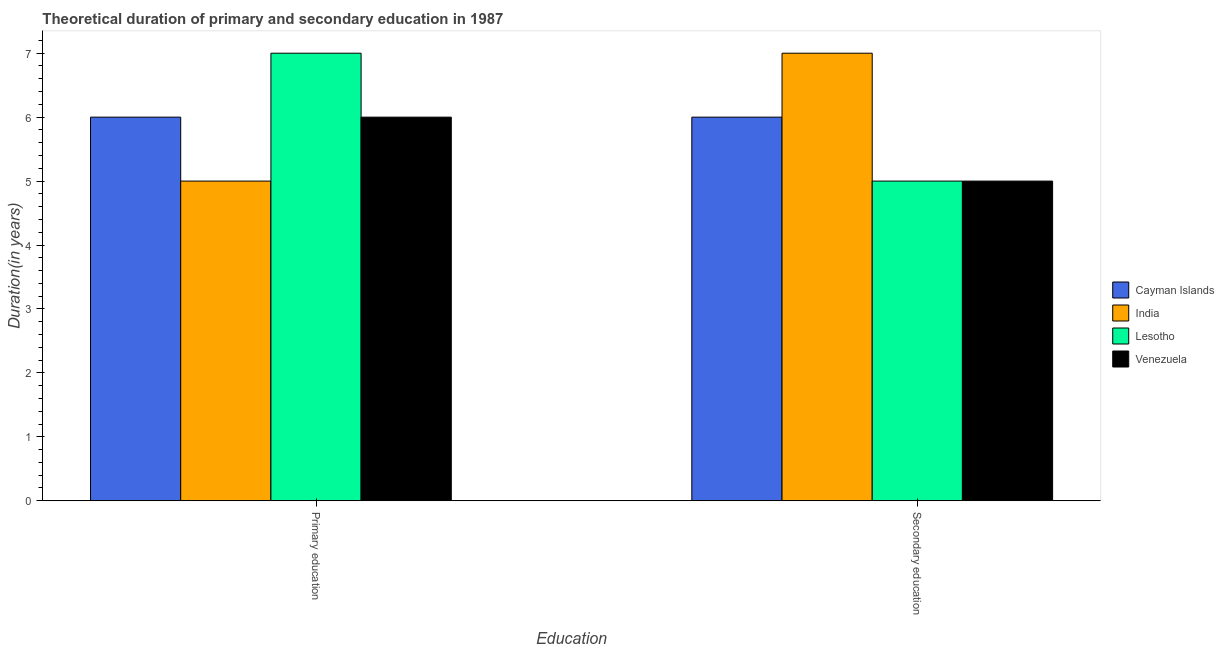How many different coloured bars are there?
Ensure brevity in your answer.  4. How many groups of bars are there?
Your response must be concise. 2. How many bars are there on the 1st tick from the left?
Ensure brevity in your answer.  4. How many bars are there on the 2nd tick from the right?
Provide a succinct answer. 4. What is the label of the 2nd group of bars from the left?
Keep it short and to the point. Secondary education. What is the duration of primary education in Lesotho?
Give a very brief answer. 7. Across all countries, what is the maximum duration of secondary education?
Give a very brief answer. 7. Across all countries, what is the minimum duration of secondary education?
Your answer should be very brief. 5. In which country was the duration of primary education maximum?
Make the answer very short. Lesotho. What is the total duration of secondary education in the graph?
Ensure brevity in your answer.  23. What is the difference between the duration of primary education in Cayman Islands and that in Venezuela?
Offer a very short reply. 0. What is the difference between the duration of secondary education in India and the duration of primary education in Lesotho?
Ensure brevity in your answer.  0. What is the average duration of secondary education per country?
Keep it short and to the point. 5.75. What is the difference between the duration of primary education and duration of secondary education in Lesotho?
Ensure brevity in your answer.  2. Is the duration of primary education in Cayman Islands less than that in Lesotho?
Your answer should be very brief. Yes. What does the 1st bar from the left in Primary education represents?
Your answer should be compact. Cayman Islands. What does the 4th bar from the right in Primary education represents?
Provide a succinct answer. Cayman Islands. Are all the bars in the graph horizontal?
Offer a very short reply. No. How many legend labels are there?
Your answer should be very brief. 4. What is the title of the graph?
Your answer should be compact. Theoretical duration of primary and secondary education in 1987. What is the label or title of the X-axis?
Give a very brief answer. Education. What is the label or title of the Y-axis?
Provide a succinct answer. Duration(in years). What is the Duration(in years) of Venezuela in Primary education?
Provide a succinct answer. 6. What is the Duration(in years) in India in Secondary education?
Provide a succinct answer. 7. Across all Education, what is the maximum Duration(in years) of India?
Ensure brevity in your answer.  7. Across all Education, what is the maximum Duration(in years) in Lesotho?
Provide a short and direct response. 7. Across all Education, what is the minimum Duration(in years) of Cayman Islands?
Your answer should be very brief. 6. Across all Education, what is the minimum Duration(in years) in India?
Provide a short and direct response. 5. What is the total Duration(in years) of Lesotho in the graph?
Ensure brevity in your answer.  12. What is the difference between the Duration(in years) in Cayman Islands in Primary education and that in Secondary education?
Make the answer very short. 0. What is the difference between the Duration(in years) of India in Primary education and that in Secondary education?
Provide a succinct answer. -2. What is the difference between the Duration(in years) in Lesotho in Primary education and that in Secondary education?
Keep it short and to the point. 2. What is the difference between the Duration(in years) in Cayman Islands in Primary education and the Duration(in years) in Lesotho in Secondary education?
Your answer should be very brief. 1. What is the difference between the Duration(in years) in Cayman Islands in Primary education and the Duration(in years) in Venezuela in Secondary education?
Offer a terse response. 1. What is the difference between the Duration(in years) of India in Primary education and the Duration(in years) of Lesotho in Secondary education?
Keep it short and to the point. 0. What is the difference between the Duration(in years) in Lesotho in Primary education and the Duration(in years) in Venezuela in Secondary education?
Give a very brief answer. 2. What is the average Duration(in years) of Cayman Islands per Education?
Offer a very short reply. 6. What is the average Duration(in years) of India per Education?
Your answer should be compact. 6. What is the average Duration(in years) in Lesotho per Education?
Ensure brevity in your answer.  6. What is the average Duration(in years) of Venezuela per Education?
Provide a succinct answer. 5.5. What is the difference between the Duration(in years) of Cayman Islands and Duration(in years) of India in Primary education?
Offer a very short reply. 1. What is the difference between the Duration(in years) of Cayman Islands and Duration(in years) of Lesotho in Primary education?
Give a very brief answer. -1. What is the difference between the Duration(in years) of Cayman Islands and Duration(in years) of Venezuela in Primary education?
Give a very brief answer. 0. What is the difference between the Duration(in years) in Cayman Islands and Duration(in years) in Lesotho in Secondary education?
Provide a short and direct response. 1. What is the difference between the Duration(in years) in Cayman Islands and Duration(in years) in Venezuela in Secondary education?
Give a very brief answer. 1. What is the difference between the Duration(in years) in Lesotho and Duration(in years) in Venezuela in Secondary education?
Offer a very short reply. 0. What is the ratio of the Duration(in years) in Venezuela in Primary education to that in Secondary education?
Give a very brief answer. 1.2. What is the difference between the highest and the second highest Duration(in years) of Cayman Islands?
Make the answer very short. 0. What is the difference between the highest and the second highest Duration(in years) in Lesotho?
Your answer should be very brief. 2. What is the difference between the highest and the second highest Duration(in years) of Venezuela?
Provide a short and direct response. 1. What is the difference between the highest and the lowest Duration(in years) of Cayman Islands?
Your answer should be compact. 0. 